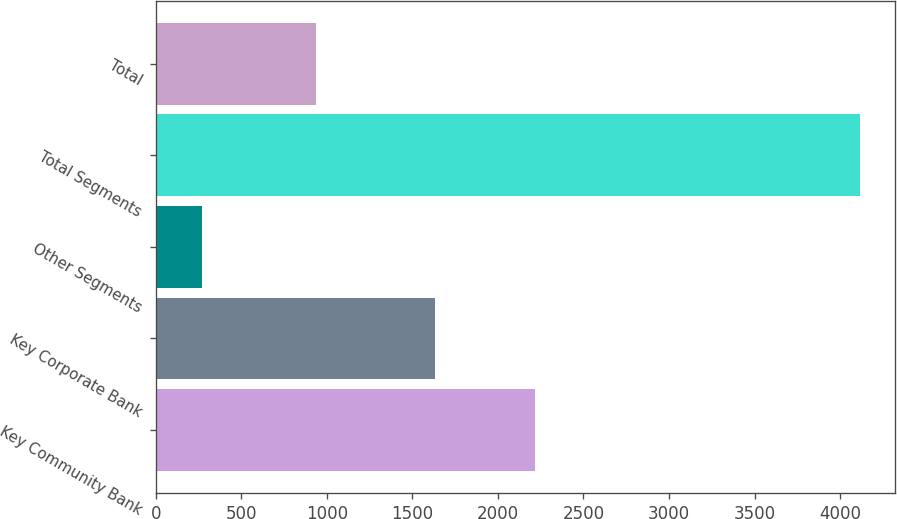<chart> <loc_0><loc_0><loc_500><loc_500><bar_chart><fcel>Key Community Bank<fcel>Key Corporate Bank<fcel>Other Segments<fcel>Total Segments<fcel>Total<nl><fcel>2217<fcel>1630<fcel>271<fcel>4118<fcel>939<nl></chart> 